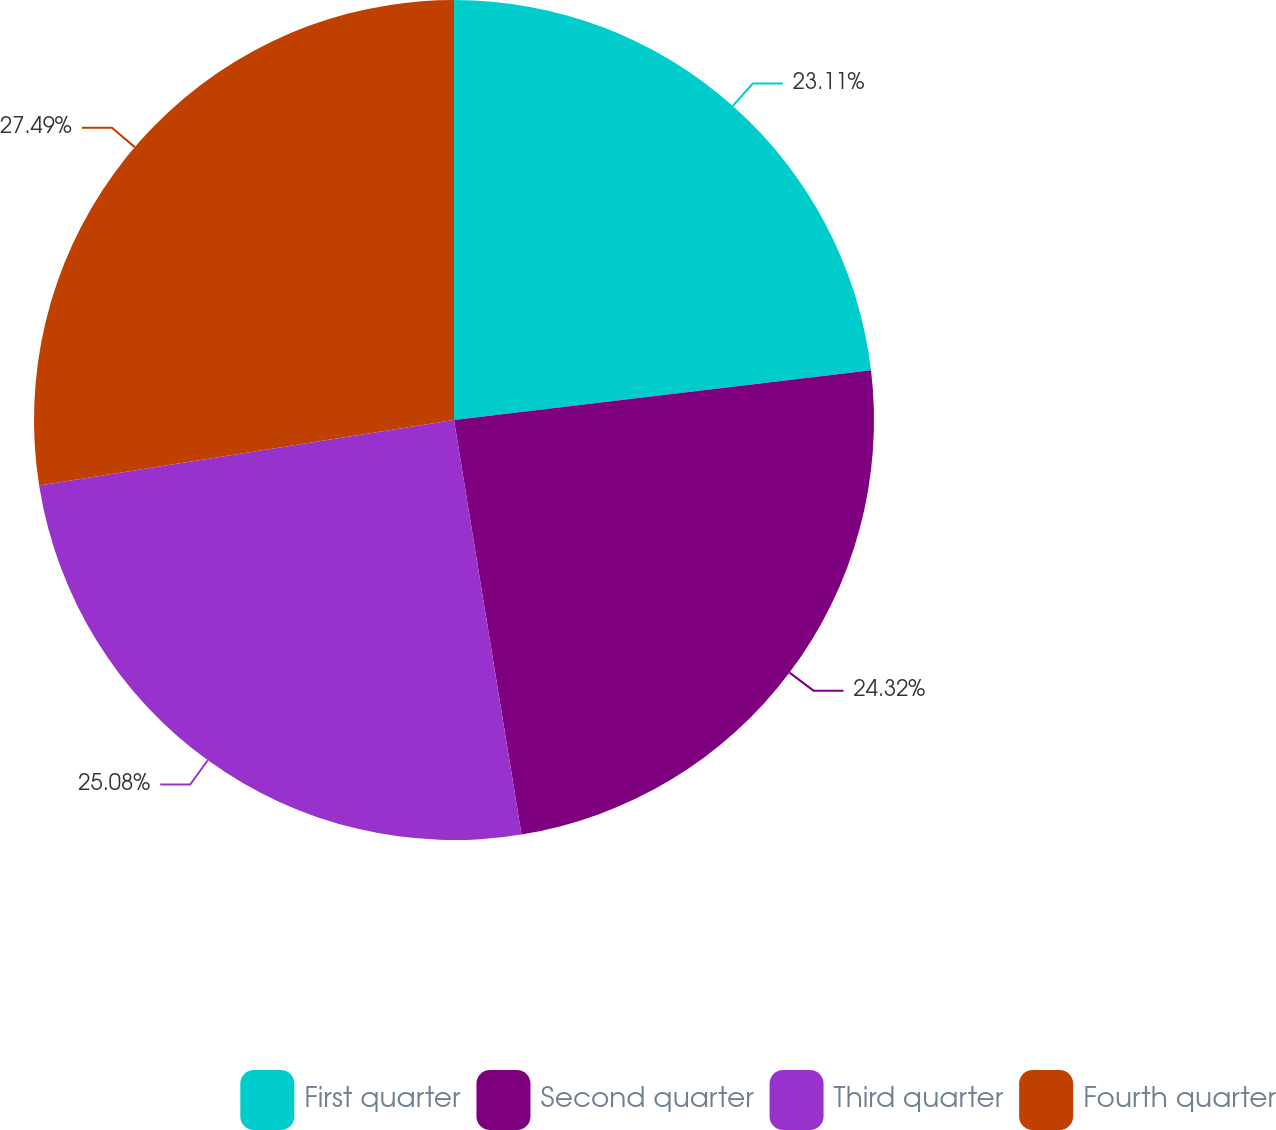<chart> <loc_0><loc_0><loc_500><loc_500><pie_chart><fcel>First quarter<fcel>Second quarter<fcel>Third quarter<fcel>Fourth quarter<nl><fcel>23.11%<fcel>24.32%<fcel>25.08%<fcel>27.49%<nl></chart> 